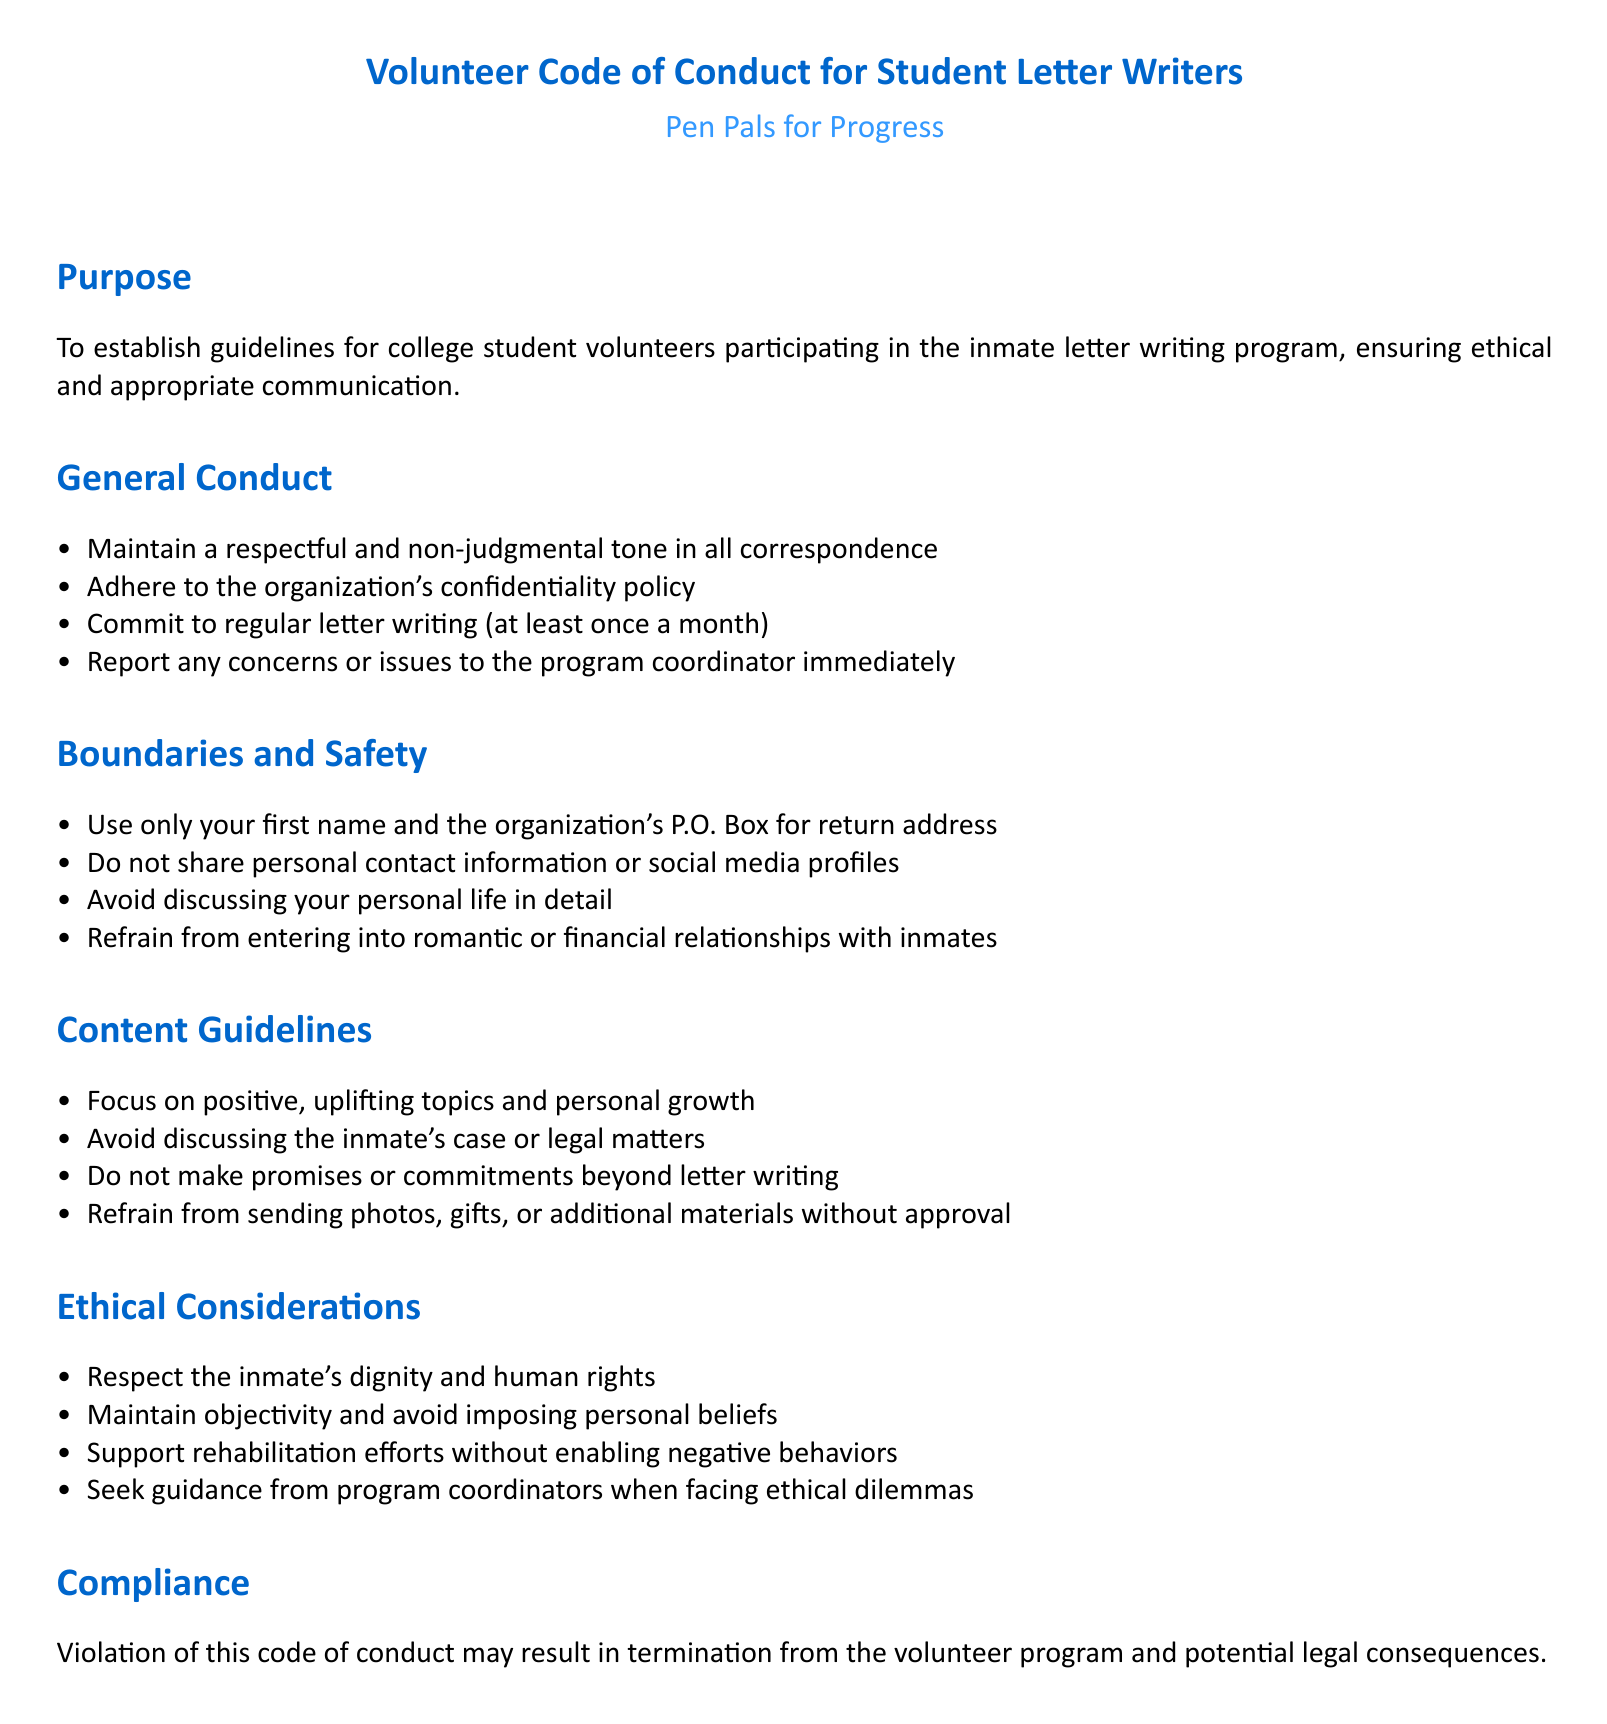What is the organization's name? The organization facilitating the letter writing program is specified as "Pen Pals for Progress."
Answer: Pen Pals for Progress How often are volunteers expected to write letters? The document states that volunteers should commit to regular letter writing at least once a month.
Answer: once a month What address should be used for return correspondence? The guidelines specify using only the organization's P.O. Box for return address without providing personal information.
Answer: organization's P.O. Box What should volunteers avoid discussing in letters? Volunteers are instructed to avoid discussing the inmate's case or legal matters in their correspondence.
Answer: inmate's case or legal matters What is the consequence of violating the code of conduct? The document mentions that a violation may result in termination from the volunteer program as well as potential legal consequences.
Answer: termination from the volunteer program Which aspect of interaction is emphasized regarding inmate relationships? The guidelines explicitly state that volunteers should refrain from entering into romantic or financial relationships with inmates.
Answer: refrain from romantic or financial relationships What is emphasized regarding the tone of correspondence? The document highlights the importance of maintaining a respectful and non-judgmental tone in all communication with inmates.
Answer: respectful and non-judgmental tone What should volunteers do if they face ethical dilemmas? When dealing with ethical issues, it is recommended to seek guidance from program coordinators.
Answer: seek guidance from program coordinators What is the focus of the letter content as per guidelines? The content should focus on positive, uplifting topics and personal growth according to the guidelines.
Answer: positive, uplifting topics and personal growth 